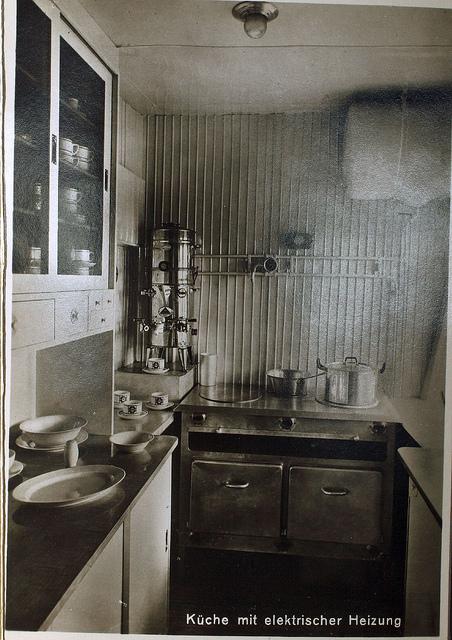Was this picture taken in the last 5 years?
Quick response, please. No. Is this a kitchen restaurant?
Write a very short answer. No. Is this photo old?
Short answer required. Yes. Is the light in the kitchen on?
Concise answer only. No. Is this a bakery window?
Write a very short answer. No. Does this person live in an urban or rural area?
Give a very brief answer. Rural. Is that a bathroom?
Quick response, please. No. Is the light turned on?
Keep it brief. No. 